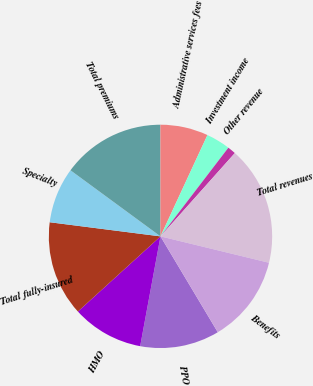<chart> <loc_0><loc_0><loc_500><loc_500><pie_chart><fcel>PPO<fcel>HMO<fcel>Total fully-insured<fcel>Specialty<fcel>Total premiums<fcel>Administrative services fees<fcel>Investment income<fcel>Other revenue<fcel>Total revenues<fcel>Benefits<nl><fcel>11.49%<fcel>10.34%<fcel>13.77%<fcel>8.06%<fcel>14.91%<fcel>6.92%<fcel>3.49%<fcel>1.2%<fcel>17.2%<fcel>12.63%<nl></chart> 